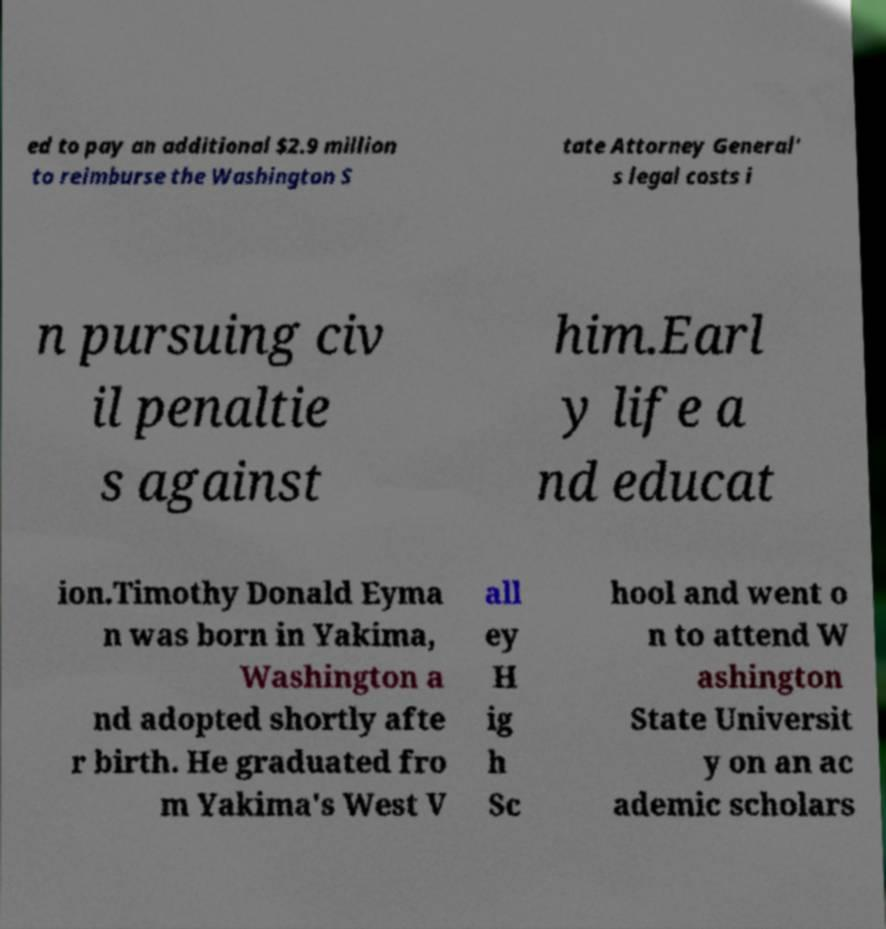I need the written content from this picture converted into text. Can you do that? ed to pay an additional $2.9 million to reimburse the Washington S tate Attorney General' s legal costs i n pursuing civ il penaltie s against him.Earl y life a nd educat ion.Timothy Donald Eyma n was born in Yakima, Washington a nd adopted shortly afte r birth. He graduated fro m Yakima's West V all ey H ig h Sc hool and went o n to attend W ashington State Universit y on an ac ademic scholars 